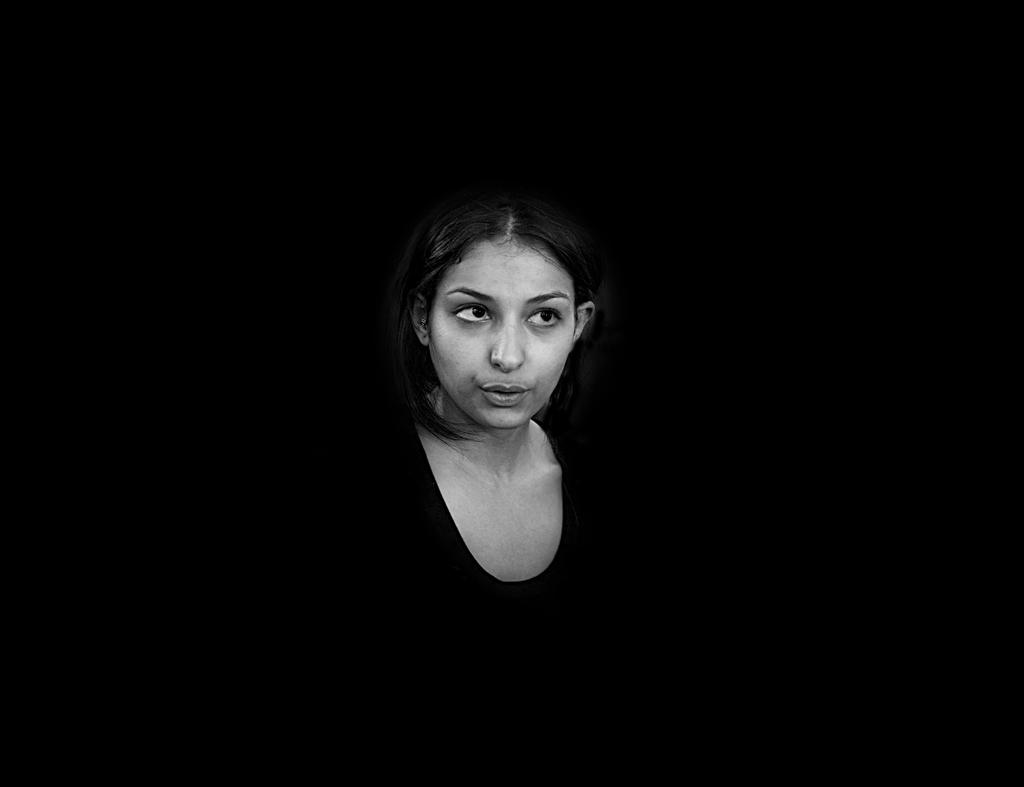Who is the main subject in the image? There is a woman in the center of the image. What can be observed about the environment around the woman? The surrounding of the woman is dark. What type of image is this? The image appears to be animated. How many cats are sitting on the bottle in the image? There are no cats or bottles present in the image. What type of sail is visible in the image? There is no sail present in the image. 